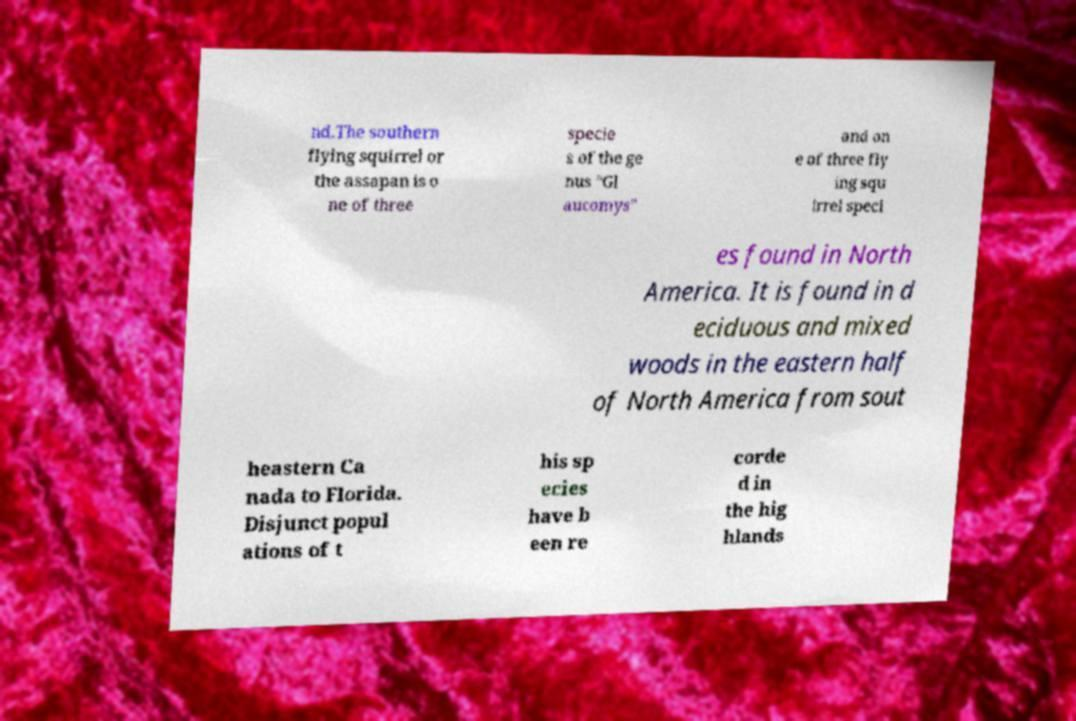Can you read and provide the text displayed in the image?This photo seems to have some interesting text. Can you extract and type it out for me? nd.The southern flying squirrel or the assapan is o ne of three specie s of the ge nus "Gl aucomys" and on e of three fly ing squ irrel speci es found in North America. It is found in d eciduous and mixed woods in the eastern half of North America from sout heastern Ca nada to Florida. Disjunct popul ations of t his sp ecies have b een re corde d in the hig hlands 